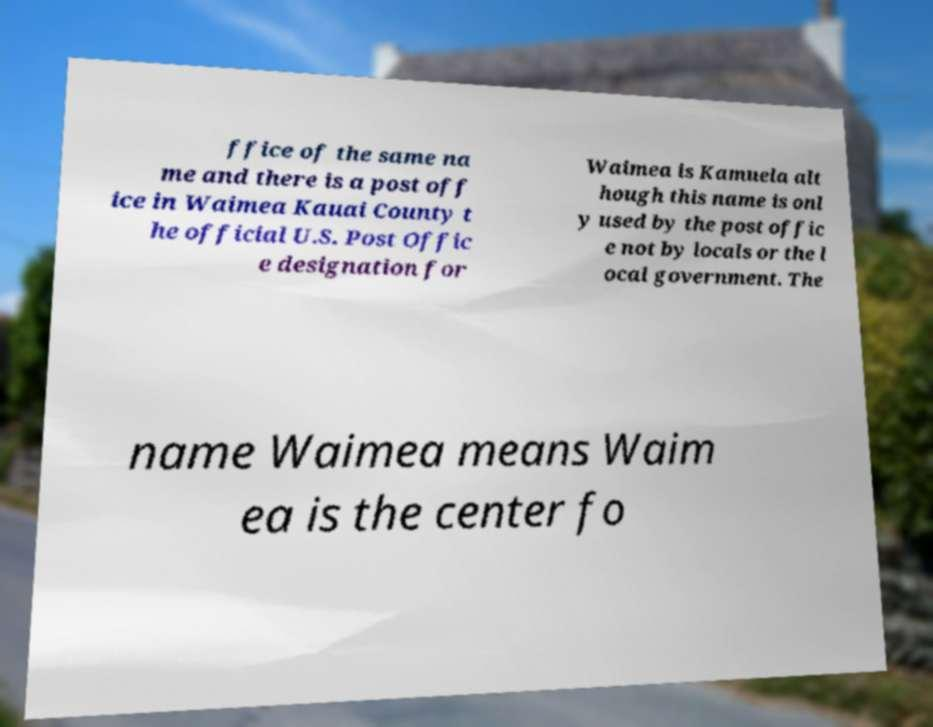Could you extract and type out the text from this image? ffice of the same na me and there is a post off ice in Waimea Kauai County t he official U.S. Post Offic e designation for Waimea is Kamuela alt hough this name is onl y used by the post offic e not by locals or the l ocal government. The name Waimea means Waim ea is the center fo 